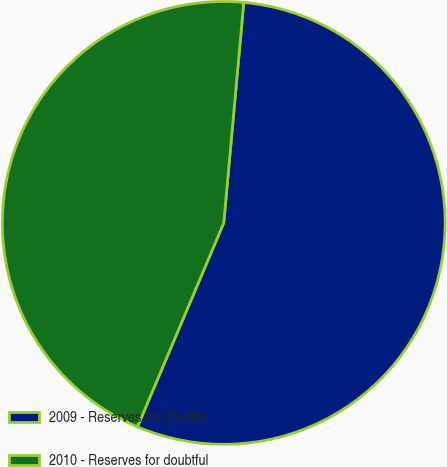Convert chart to OTSL. <chart><loc_0><loc_0><loc_500><loc_500><pie_chart><fcel>2009 - Reserves for doubtful<fcel>2010 - Reserves for doubtful<nl><fcel>54.93%<fcel>45.07%<nl></chart> 